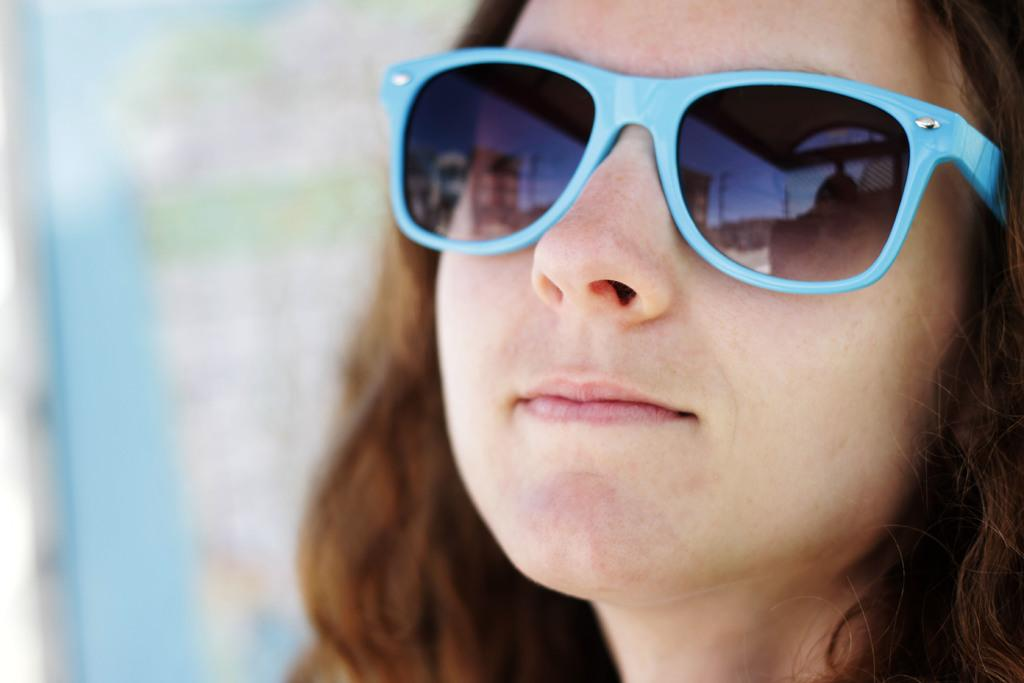Who is the main subject in the image? There is a woman in the image. What part of the woman can be seen in the image? Only the woman's face is visible in the image. What is the woman wearing on her face? The woman is wearing goggles. How many mint leaves can be seen in the woman's hair in the image? There are no mint leaves present in the image. 